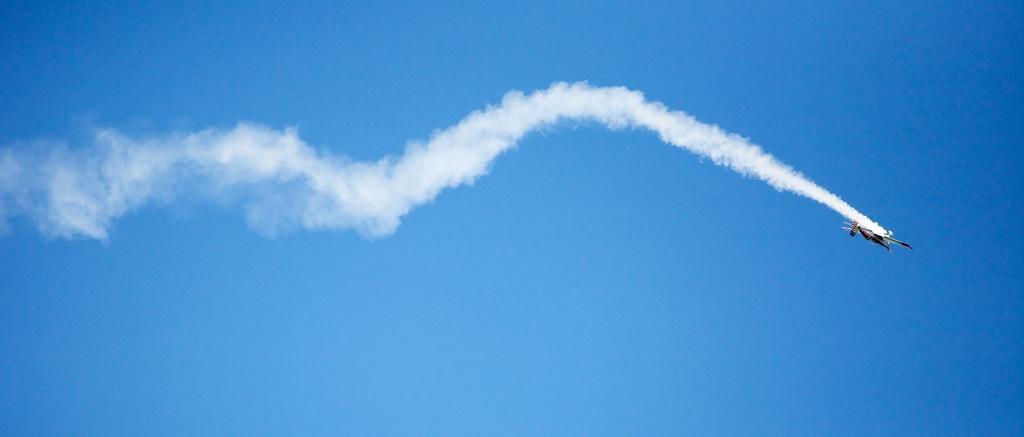Could you give a brief overview of what you see in this image? In this image I can see an aircraft which is in the air. And I can see the white color smoke to an aircraft. In the back I can see the blue sky. 